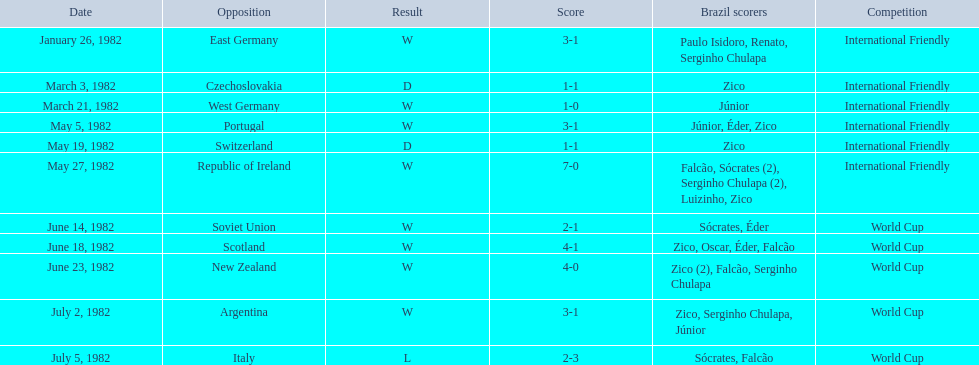How many games did zico end up scoring in during this season? 7. 